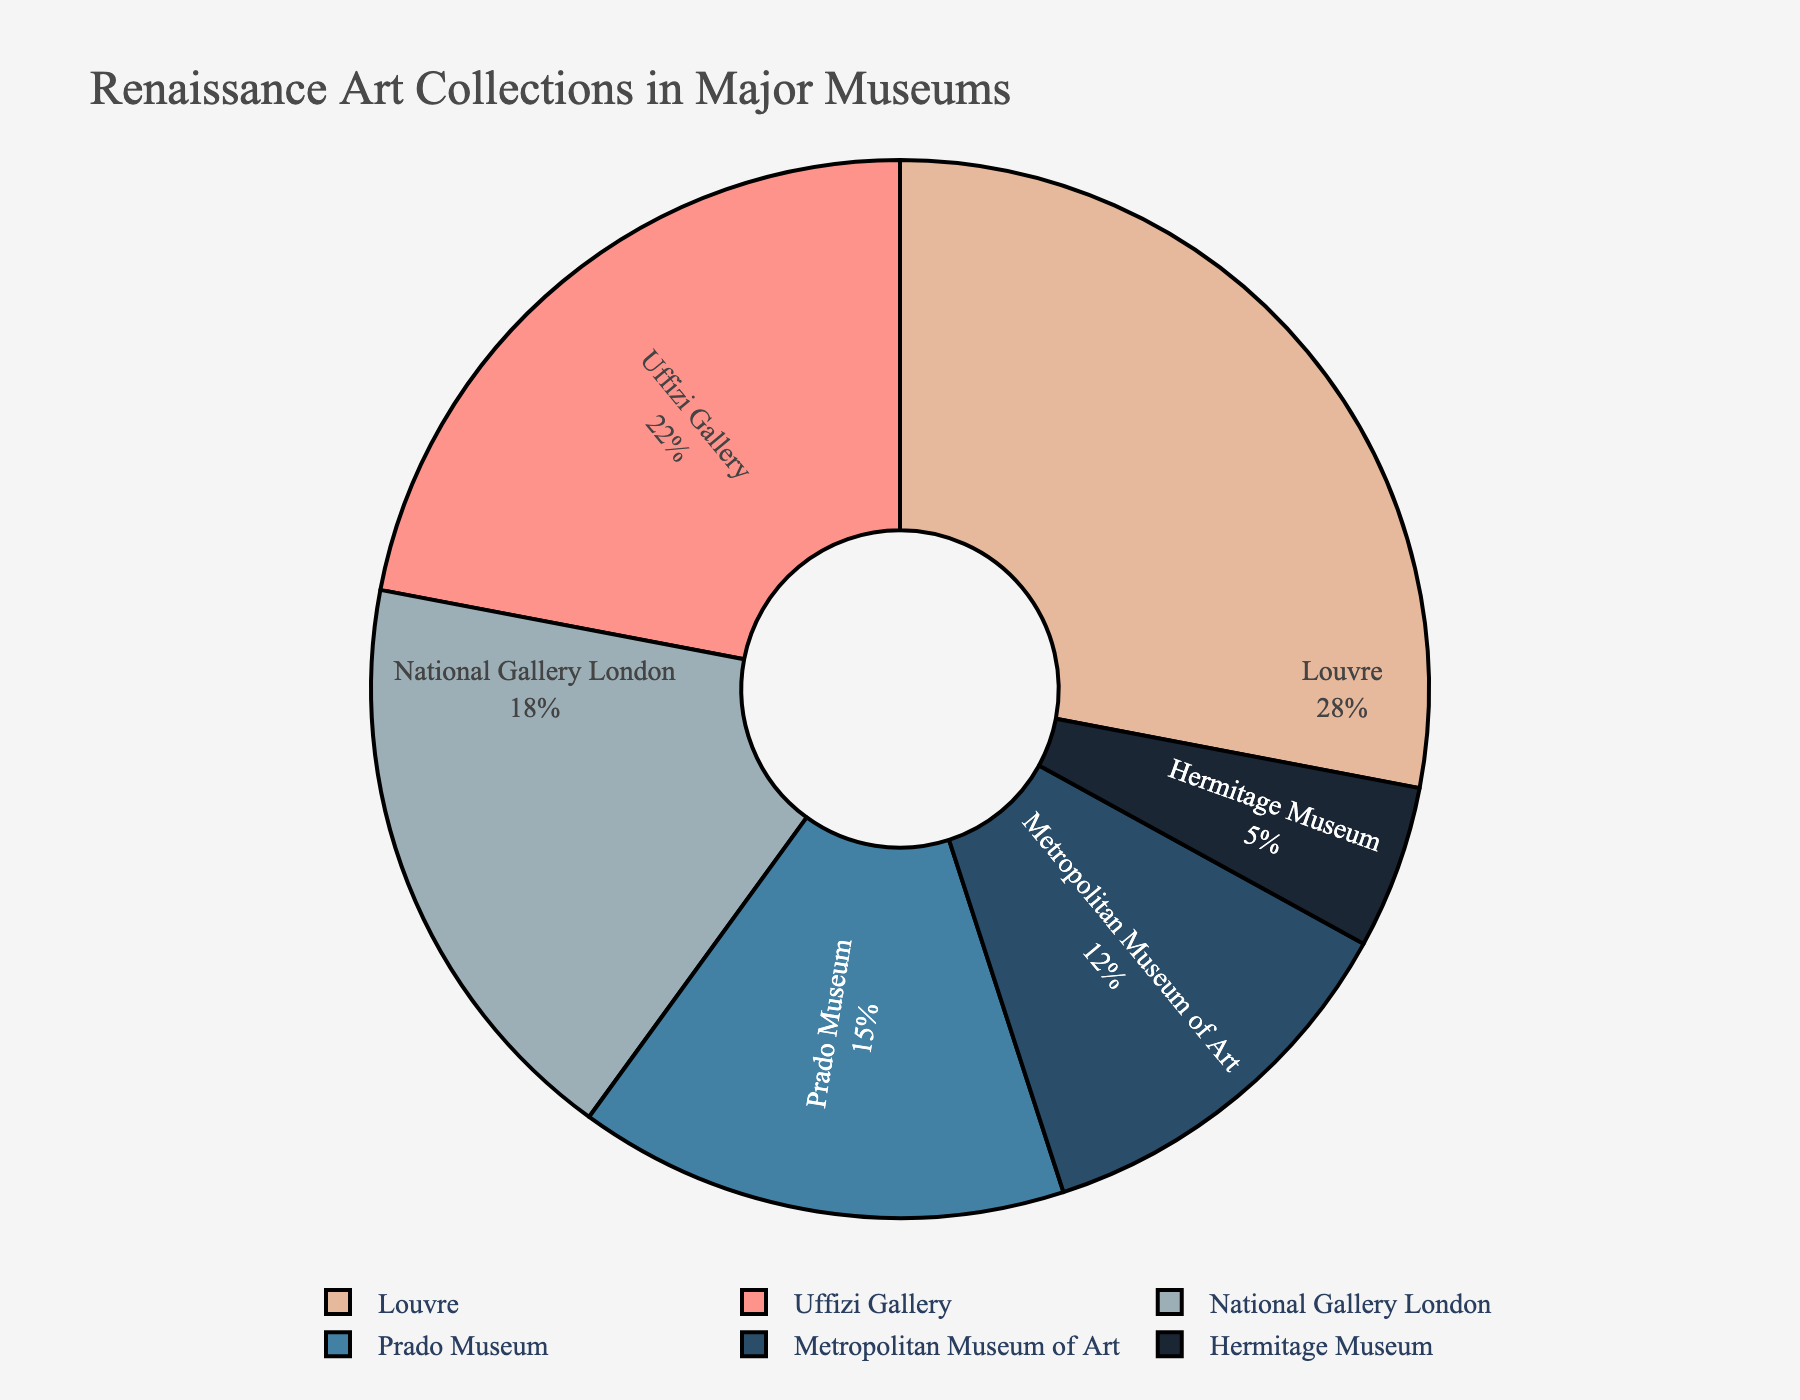What's the highest proportion of Renaissance art collections among the museums? The highest proportion is represented by the largest segment in the pie chart. The Louvre has the largest slice.
Answer: Louvre Which museums have a smaller proportion of Renaissance art collections than the Uffizi Gallery? We need to compare the Uffizi Gallery slice with the rest. The museums with smaller proportions than the Uffizi are the National Gallery, Prado, Metropolitan Museum of Art, and Hermitage Museum.
Answer: National Gallery, Prado, Metropolitan Museum of Art, Hermitage Museum What is the combined proportion of Renaissance art collections in the Louvre and Prado Museum? Add the proportions of the Louvre and Prado Museum slices (28% + 15%).
Answer: 43% Which museum has the smallest proportion, and what is that proportion? Identify the smallest slice in the pie chart, which represents the Hermitage Museum, with 5%.
Answer: Hermitage Museum, 5% Is the proportion of Renaissance art collections in the National Gallery greater than that in the Metropolitan Museum of Art? Compare the slices for the National Gallery (18%) and the Metropolitan Museum (12%) to see which is larger.
Answer: Yes What is the proportion difference between the Uffizi Gallery and the National Gallery? Subtract the National Gallery proportion from the Uffizi Gallery proportion (22% - 18%).
Answer: 4% Which color represents the Uffizi Gallery in the pie chart, and what is its proportion? Identify the slice colored in light pink, which represents the Uffizi Gallery at 22%.
Answer: Light pink, 22% By how much does the proportion of Renaissance art collections in the Louvre exceed that in the Metropolitan Museum of Art? Subtract the Metropolitan Museum's proportion from the Louvre's proportion (28% - 12%).
Answer: 16% What is the visual attribute that distinguishes the Prado Museum's slice from others? The slice for the Prado Museum is distinguished by its blue color.
Answer: Blue Combining the proportions of museums with less than 20% of Renaissance art collections, what is the total percentage? Add up the proportions for the National Gallery, Prado Museum, Metropolitan Museum of Art, and Hermitage Museum (18% + 15% + 12% + 5%).
Answer: 50% 